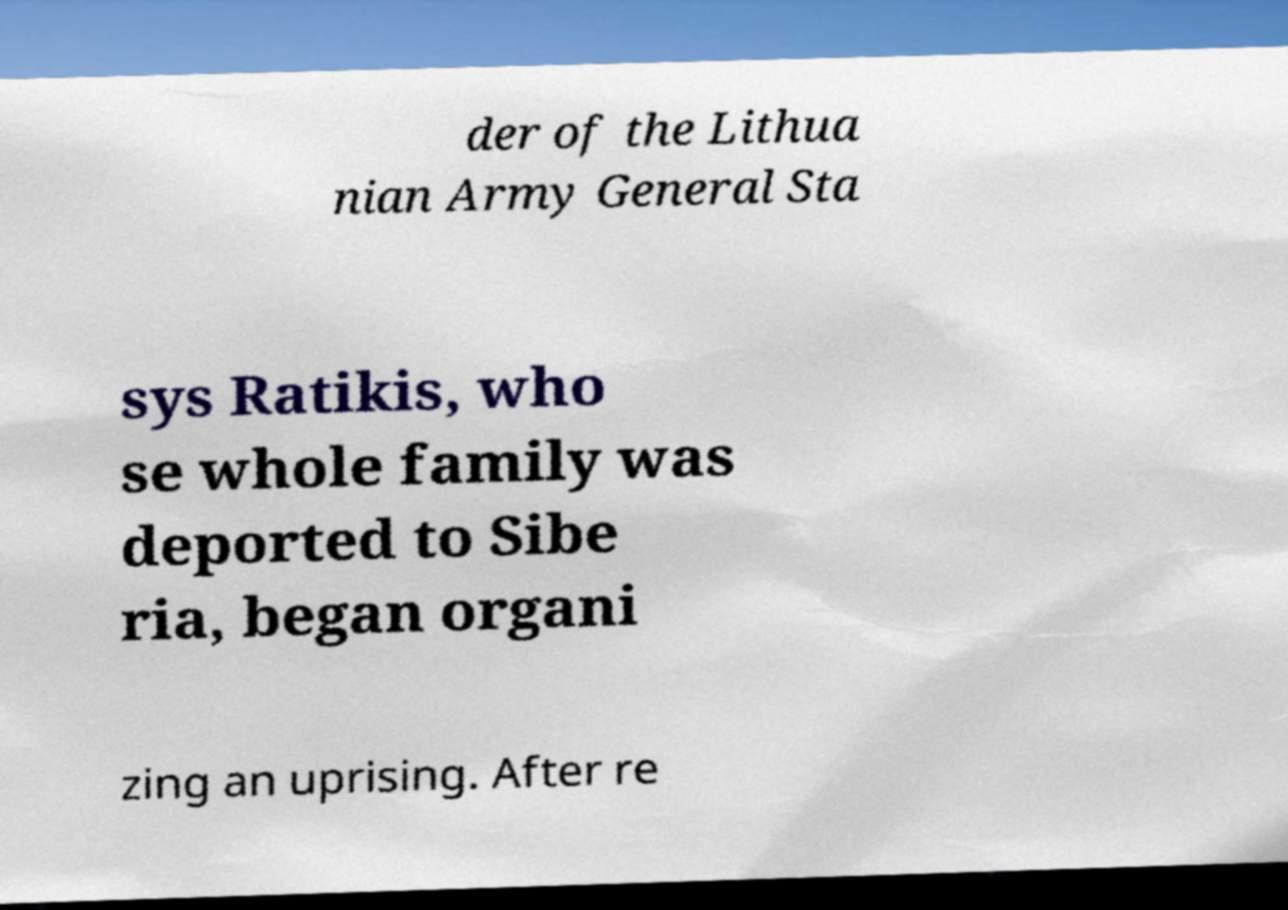Can you read and provide the text displayed in the image?This photo seems to have some interesting text. Can you extract and type it out for me? der of the Lithua nian Army General Sta sys Ratikis, who se whole family was deported to Sibe ria, began organi zing an uprising. After re 